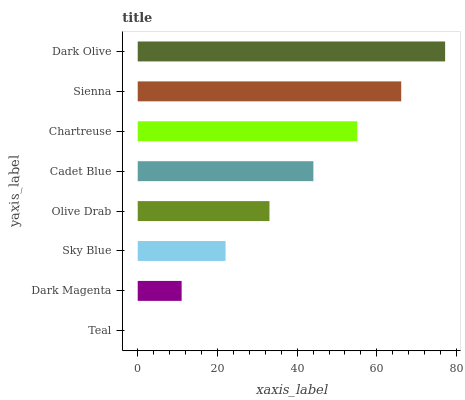Is Teal the minimum?
Answer yes or no. Yes. Is Dark Olive the maximum?
Answer yes or no. Yes. Is Dark Magenta the minimum?
Answer yes or no. No. Is Dark Magenta the maximum?
Answer yes or no. No. Is Dark Magenta greater than Teal?
Answer yes or no. Yes. Is Teal less than Dark Magenta?
Answer yes or no. Yes. Is Teal greater than Dark Magenta?
Answer yes or no. No. Is Dark Magenta less than Teal?
Answer yes or no. No. Is Cadet Blue the high median?
Answer yes or no. Yes. Is Olive Drab the low median?
Answer yes or no. Yes. Is Dark Magenta the high median?
Answer yes or no. No. Is Dark Magenta the low median?
Answer yes or no. No. 